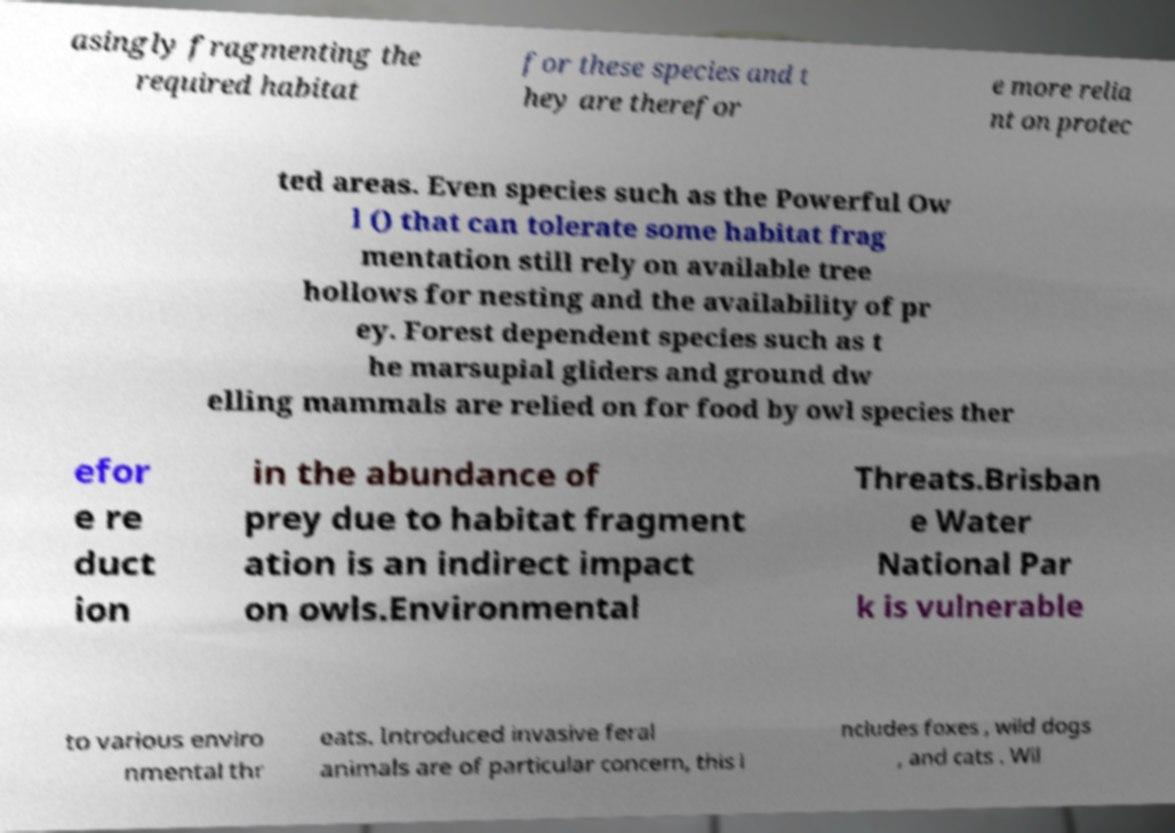Can you read and provide the text displayed in the image?This photo seems to have some interesting text. Can you extract and type it out for me? asingly fragmenting the required habitat for these species and t hey are therefor e more relia nt on protec ted areas. Even species such as the Powerful Ow l () that can tolerate some habitat frag mentation still rely on available tree hollows for nesting and the availability of pr ey. Forest dependent species such as t he marsupial gliders and ground dw elling mammals are relied on for food by owl species ther efor e re duct ion in the abundance of prey due to habitat fragment ation is an indirect impact on owls.Environmental Threats.Brisban e Water National Par k is vulnerable to various enviro nmental thr eats. Introduced invasive feral animals are of particular concern, this i ncludes foxes , wild dogs , and cats . Wil 